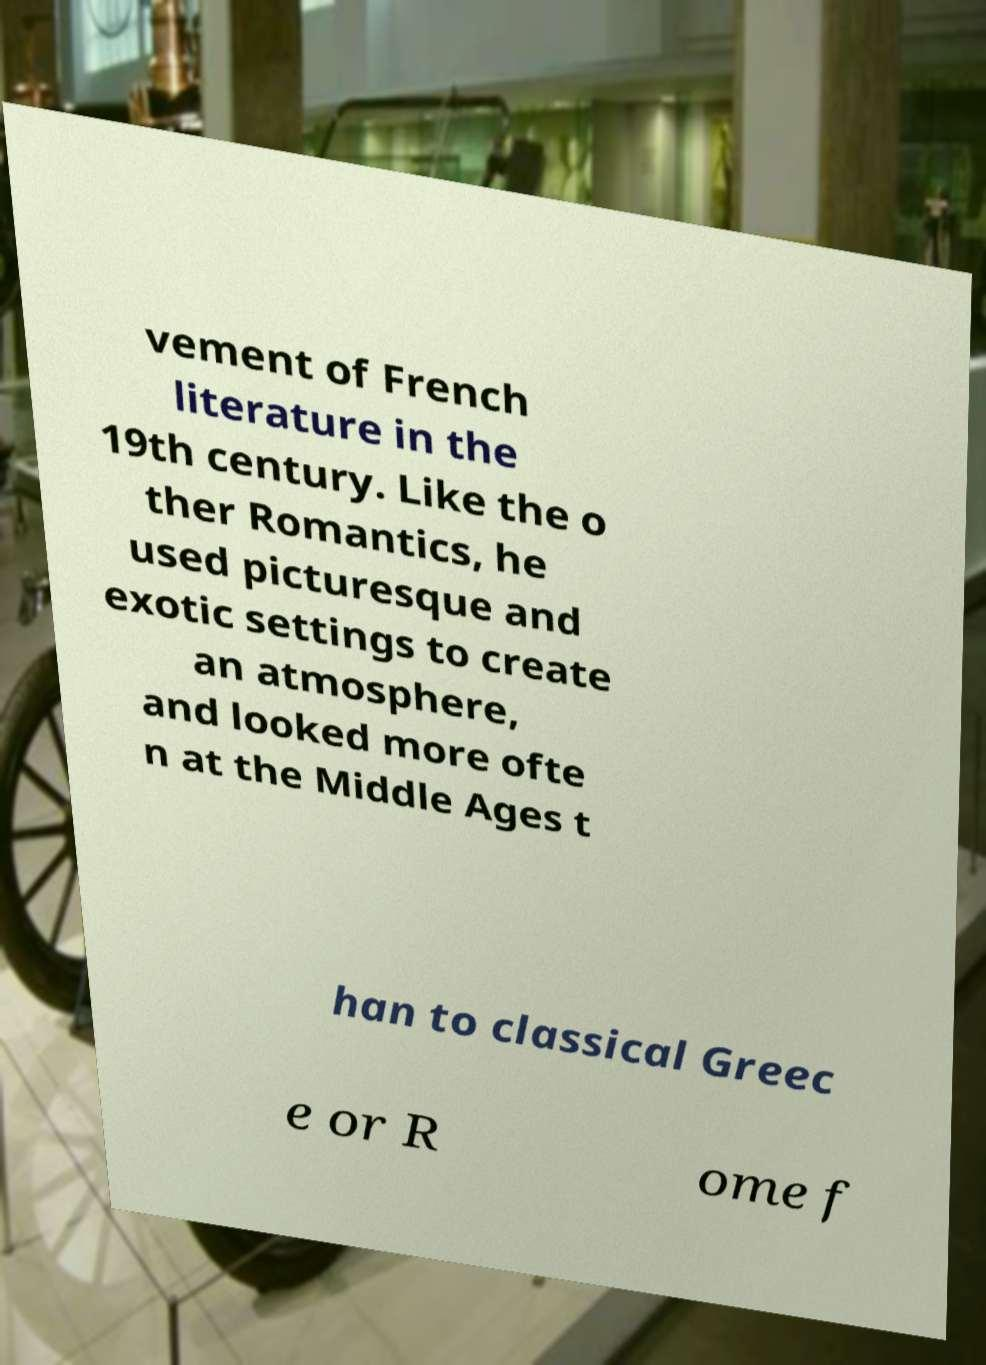Please identify and transcribe the text found in this image. vement of French literature in the 19th century. Like the o ther Romantics, he used picturesque and exotic settings to create an atmosphere, and looked more ofte n at the Middle Ages t han to classical Greec e or R ome f 